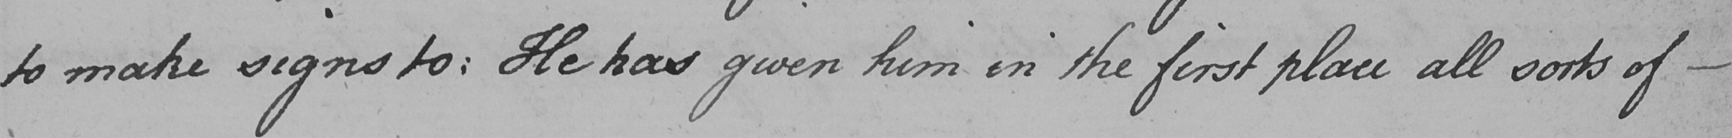What does this handwritten line say? to make signs to :  He has given him in the first place all sorts of  _ 